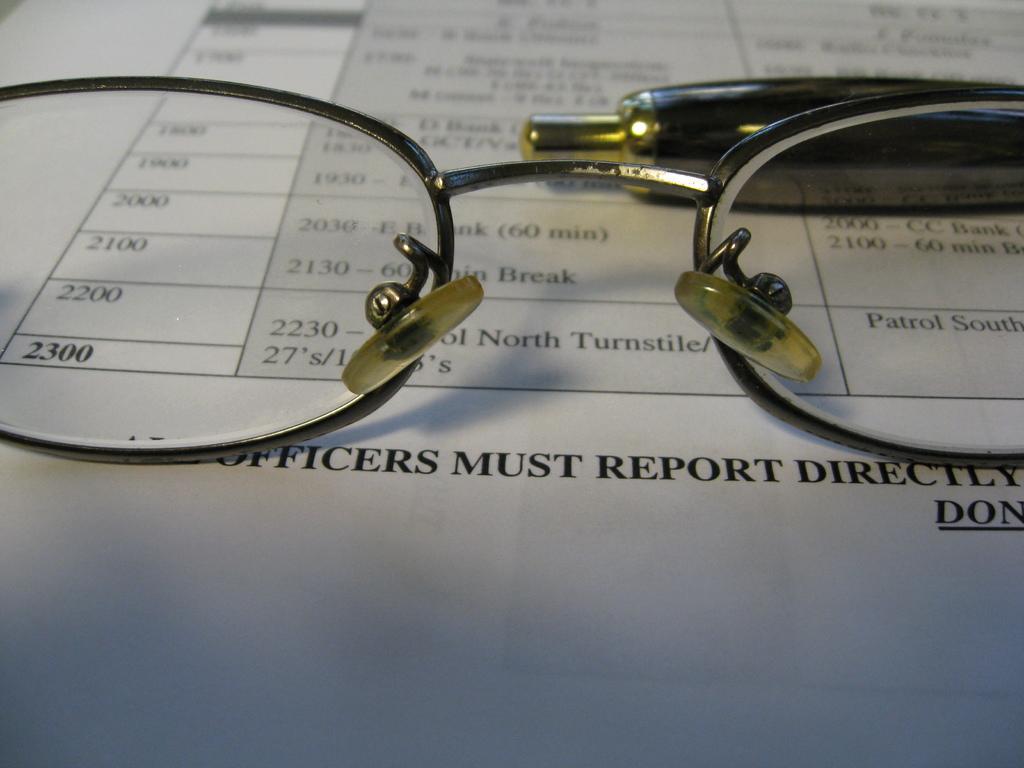Could you give a brief overview of what you see in this image? In the foreground of this picture we can see the spectacles and a pen like object and we can see the text and numbers on the paper which is in the background. 